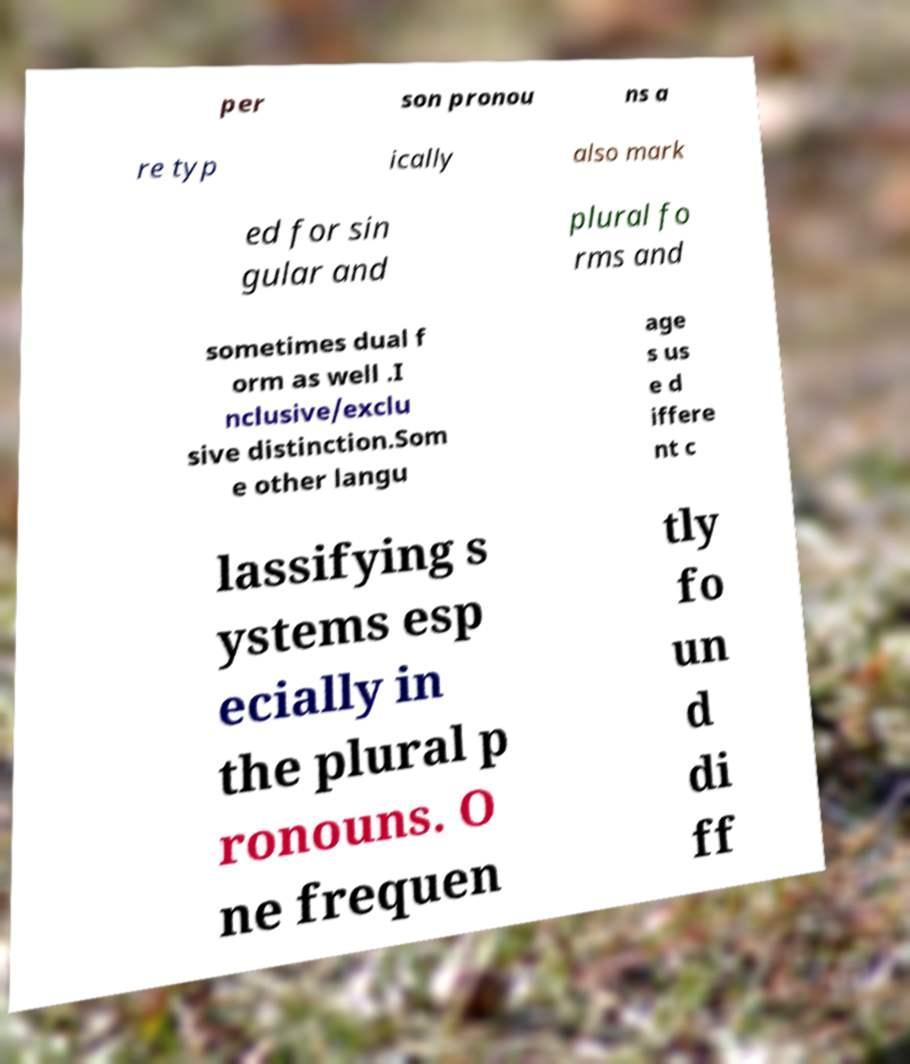Can you accurately transcribe the text from the provided image for me? per son pronou ns a re typ ically also mark ed for sin gular and plural fo rms and sometimes dual f orm as well .I nclusive/exclu sive distinction.Som e other langu age s us e d iffere nt c lassifying s ystems esp ecially in the plural p ronouns. O ne frequen tly fo un d di ff 